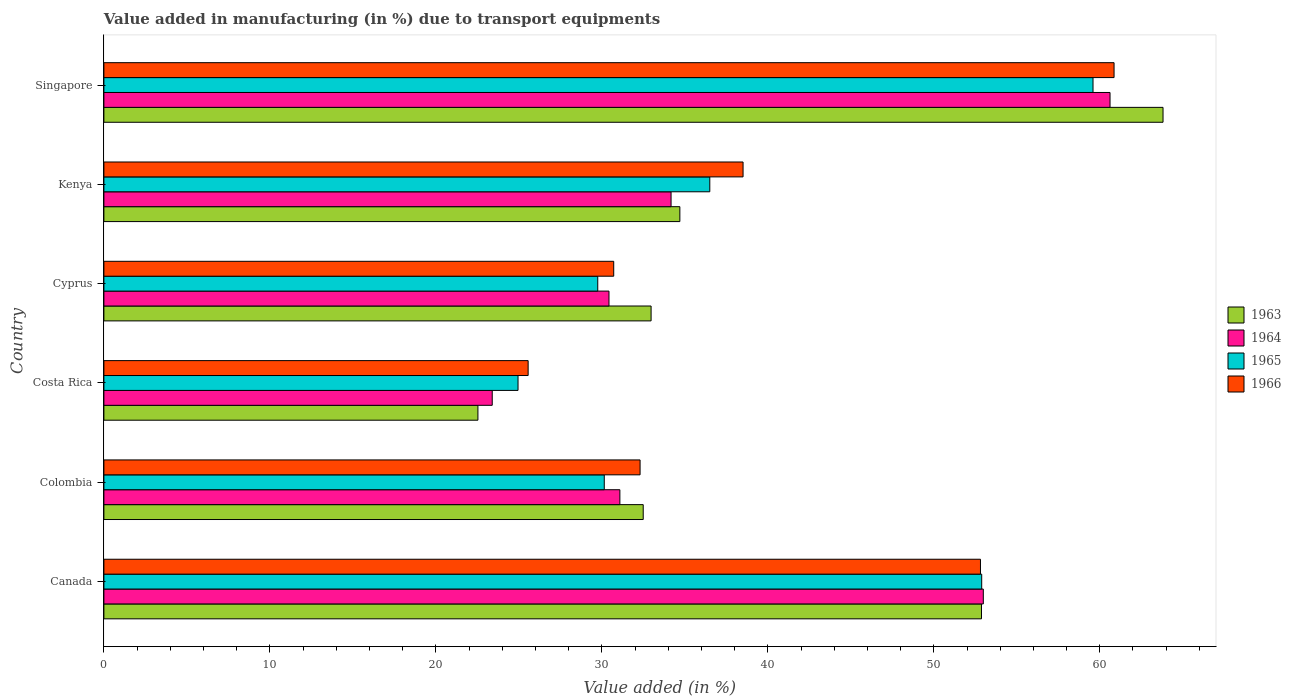How many groups of bars are there?
Offer a terse response. 6. Are the number of bars per tick equal to the number of legend labels?
Keep it short and to the point. Yes. Are the number of bars on each tick of the Y-axis equal?
Make the answer very short. Yes. What is the label of the 6th group of bars from the top?
Provide a short and direct response. Canada. In how many cases, is the number of bars for a given country not equal to the number of legend labels?
Your answer should be very brief. 0. What is the percentage of value added in manufacturing due to transport equipments in 1963 in Cyprus?
Your answer should be compact. 32.97. Across all countries, what is the maximum percentage of value added in manufacturing due to transport equipments in 1965?
Your response must be concise. 59.59. Across all countries, what is the minimum percentage of value added in manufacturing due to transport equipments in 1965?
Your answer should be very brief. 24.95. In which country was the percentage of value added in manufacturing due to transport equipments in 1965 maximum?
Provide a short and direct response. Singapore. What is the total percentage of value added in manufacturing due to transport equipments in 1964 in the graph?
Offer a terse response. 232.68. What is the difference between the percentage of value added in manufacturing due to transport equipments in 1964 in Colombia and that in Costa Rica?
Offer a terse response. 7.69. What is the difference between the percentage of value added in manufacturing due to transport equipments in 1965 in Colombia and the percentage of value added in manufacturing due to transport equipments in 1963 in Kenya?
Your answer should be compact. -4.55. What is the average percentage of value added in manufacturing due to transport equipments in 1963 per country?
Offer a terse response. 39.9. What is the difference between the percentage of value added in manufacturing due to transport equipments in 1963 and percentage of value added in manufacturing due to transport equipments in 1965 in Kenya?
Offer a terse response. -1.8. What is the ratio of the percentage of value added in manufacturing due to transport equipments in 1965 in Costa Rica to that in Cyprus?
Give a very brief answer. 0.84. Is the percentage of value added in manufacturing due to transport equipments in 1966 in Cyprus less than that in Kenya?
Give a very brief answer. Yes. What is the difference between the highest and the second highest percentage of value added in manufacturing due to transport equipments in 1964?
Provide a succinct answer. 7.63. What is the difference between the highest and the lowest percentage of value added in manufacturing due to transport equipments in 1966?
Keep it short and to the point. 35.3. In how many countries, is the percentage of value added in manufacturing due to transport equipments in 1966 greater than the average percentage of value added in manufacturing due to transport equipments in 1966 taken over all countries?
Provide a succinct answer. 2. Is it the case that in every country, the sum of the percentage of value added in manufacturing due to transport equipments in 1966 and percentage of value added in manufacturing due to transport equipments in 1964 is greater than the sum of percentage of value added in manufacturing due to transport equipments in 1965 and percentage of value added in manufacturing due to transport equipments in 1963?
Your response must be concise. No. What does the 2nd bar from the bottom in Costa Rica represents?
Provide a short and direct response. 1964. Is it the case that in every country, the sum of the percentage of value added in manufacturing due to transport equipments in 1966 and percentage of value added in manufacturing due to transport equipments in 1964 is greater than the percentage of value added in manufacturing due to transport equipments in 1965?
Your response must be concise. Yes. How many bars are there?
Keep it short and to the point. 24. How many countries are there in the graph?
Your response must be concise. 6. What is the difference between two consecutive major ticks on the X-axis?
Give a very brief answer. 10. Are the values on the major ticks of X-axis written in scientific E-notation?
Your answer should be compact. No. How many legend labels are there?
Your answer should be compact. 4. What is the title of the graph?
Offer a very short reply. Value added in manufacturing (in %) due to transport equipments. Does "1976" appear as one of the legend labels in the graph?
Give a very brief answer. No. What is the label or title of the X-axis?
Provide a short and direct response. Value added (in %). What is the label or title of the Y-axis?
Keep it short and to the point. Country. What is the Value added (in %) in 1963 in Canada?
Keep it short and to the point. 52.87. What is the Value added (in %) of 1964 in Canada?
Give a very brief answer. 52.98. What is the Value added (in %) of 1965 in Canada?
Ensure brevity in your answer.  52.89. What is the Value added (in %) of 1966 in Canada?
Ensure brevity in your answer.  52.81. What is the Value added (in %) in 1963 in Colombia?
Your answer should be very brief. 32.49. What is the Value added (in %) in 1964 in Colombia?
Your answer should be compact. 31.09. What is the Value added (in %) of 1965 in Colombia?
Make the answer very short. 30.15. What is the Value added (in %) in 1966 in Colombia?
Provide a succinct answer. 32.3. What is the Value added (in %) of 1963 in Costa Rica?
Keep it short and to the point. 22.53. What is the Value added (in %) in 1964 in Costa Rica?
Provide a succinct answer. 23.4. What is the Value added (in %) of 1965 in Costa Rica?
Your response must be concise. 24.95. What is the Value added (in %) of 1966 in Costa Rica?
Ensure brevity in your answer.  25.56. What is the Value added (in %) in 1963 in Cyprus?
Your answer should be very brief. 32.97. What is the Value added (in %) in 1964 in Cyprus?
Keep it short and to the point. 30.43. What is the Value added (in %) of 1965 in Cyprus?
Your response must be concise. 29.75. What is the Value added (in %) in 1966 in Cyprus?
Make the answer very short. 30.72. What is the Value added (in %) of 1963 in Kenya?
Your answer should be very brief. 34.7. What is the Value added (in %) of 1964 in Kenya?
Make the answer very short. 34.17. What is the Value added (in %) of 1965 in Kenya?
Your answer should be very brief. 36.5. What is the Value added (in %) in 1966 in Kenya?
Ensure brevity in your answer.  38.51. What is the Value added (in %) of 1963 in Singapore?
Ensure brevity in your answer.  63.81. What is the Value added (in %) of 1964 in Singapore?
Make the answer very short. 60.62. What is the Value added (in %) of 1965 in Singapore?
Make the answer very short. 59.59. What is the Value added (in %) in 1966 in Singapore?
Your answer should be compact. 60.86. Across all countries, what is the maximum Value added (in %) in 1963?
Offer a terse response. 63.81. Across all countries, what is the maximum Value added (in %) in 1964?
Provide a succinct answer. 60.62. Across all countries, what is the maximum Value added (in %) of 1965?
Give a very brief answer. 59.59. Across all countries, what is the maximum Value added (in %) in 1966?
Your response must be concise. 60.86. Across all countries, what is the minimum Value added (in %) of 1963?
Make the answer very short. 22.53. Across all countries, what is the minimum Value added (in %) in 1964?
Keep it short and to the point. 23.4. Across all countries, what is the minimum Value added (in %) in 1965?
Your answer should be compact. 24.95. Across all countries, what is the minimum Value added (in %) of 1966?
Ensure brevity in your answer.  25.56. What is the total Value added (in %) of 1963 in the graph?
Ensure brevity in your answer.  239.38. What is the total Value added (in %) in 1964 in the graph?
Provide a succinct answer. 232.68. What is the total Value added (in %) in 1965 in the graph?
Provide a short and direct response. 233.83. What is the total Value added (in %) in 1966 in the graph?
Ensure brevity in your answer.  240.76. What is the difference between the Value added (in %) of 1963 in Canada and that in Colombia?
Offer a terse response. 20.38. What is the difference between the Value added (in %) in 1964 in Canada and that in Colombia?
Offer a very short reply. 21.9. What is the difference between the Value added (in %) in 1965 in Canada and that in Colombia?
Your answer should be very brief. 22.74. What is the difference between the Value added (in %) in 1966 in Canada and that in Colombia?
Provide a succinct answer. 20.51. What is the difference between the Value added (in %) in 1963 in Canada and that in Costa Rica?
Make the answer very short. 30.34. What is the difference between the Value added (in %) in 1964 in Canada and that in Costa Rica?
Offer a terse response. 29.59. What is the difference between the Value added (in %) in 1965 in Canada and that in Costa Rica?
Make the answer very short. 27.93. What is the difference between the Value added (in %) of 1966 in Canada and that in Costa Rica?
Keep it short and to the point. 27.25. What is the difference between the Value added (in %) in 1963 in Canada and that in Cyprus?
Provide a short and direct response. 19.91. What is the difference between the Value added (in %) in 1964 in Canada and that in Cyprus?
Keep it short and to the point. 22.55. What is the difference between the Value added (in %) of 1965 in Canada and that in Cyprus?
Your response must be concise. 23.13. What is the difference between the Value added (in %) in 1966 in Canada and that in Cyprus?
Offer a very short reply. 22.1. What is the difference between the Value added (in %) of 1963 in Canada and that in Kenya?
Your response must be concise. 18.17. What is the difference between the Value added (in %) of 1964 in Canada and that in Kenya?
Your response must be concise. 18.81. What is the difference between the Value added (in %) in 1965 in Canada and that in Kenya?
Provide a short and direct response. 16.38. What is the difference between the Value added (in %) in 1966 in Canada and that in Kenya?
Provide a succinct answer. 14.3. What is the difference between the Value added (in %) in 1963 in Canada and that in Singapore?
Make the answer very short. -10.94. What is the difference between the Value added (in %) in 1964 in Canada and that in Singapore?
Provide a short and direct response. -7.63. What is the difference between the Value added (in %) of 1965 in Canada and that in Singapore?
Ensure brevity in your answer.  -6.71. What is the difference between the Value added (in %) in 1966 in Canada and that in Singapore?
Provide a short and direct response. -8.05. What is the difference between the Value added (in %) in 1963 in Colombia and that in Costa Rica?
Give a very brief answer. 9.96. What is the difference between the Value added (in %) of 1964 in Colombia and that in Costa Rica?
Your answer should be very brief. 7.69. What is the difference between the Value added (in %) in 1965 in Colombia and that in Costa Rica?
Make the answer very short. 5.2. What is the difference between the Value added (in %) of 1966 in Colombia and that in Costa Rica?
Your response must be concise. 6.74. What is the difference between the Value added (in %) of 1963 in Colombia and that in Cyprus?
Keep it short and to the point. -0.47. What is the difference between the Value added (in %) in 1964 in Colombia and that in Cyprus?
Give a very brief answer. 0.66. What is the difference between the Value added (in %) of 1965 in Colombia and that in Cyprus?
Your answer should be very brief. 0.39. What is the difference between the Value added (in %) of 1966 in Colombia and that in Cyprus?
Ensure brevity in your answer.  1.59. What is the difference between the Value added (in %) of 1963 in Colombia and that in Kenya?
Make the answer very short. -2.21. What is the difference between the Value added (in %) in 1964 in Colombia and that in Kenya?
Give a very brief answer. -3.08. What is the difference between the Value added (in %) of 1965 in Colombia and that in Kenya?
Provide a succinct answer. -6.36. What is the difference between the Value added (in %) in 1966 in Colombia and that in Kenya?
Your response must be concise. -6.2. What is the difference between the Value added (in %) of 1963 in Colombia and that in Singapore?
Give a very brief answer. -31.32. What is the difference between the Value added (in %) in 1964 in Colombia and that in Singapore?
Make the answer very short. -29.53. What is the difference between the Value added (in %) of 1965 in Colombia and that in Singapore?
Keep it short and to the point. -29.45. What is the difference between the Value added (in %) in 1966 in Colombia and that in Singapore?
Offer a terse response. -28.56. What is the difference between the Value added (in %) in 1963 in Costa Rica and that in Cyprus?
Make the answer very short. -10.43. What is the difference between the Value added (in %) in 1964 in Costa Rica and that in Cyprus?
Provide a succinct answer. -7.03. What is the difference between the Value added (in %) of 1965 in Costa Rica and that in Cyprus?
Keep it short and to the point. -4.8. What is the difference between the Value added (in %) in 1966 in Costa Rica and that in Cyprus?
Offer a terse response. -5.16. What is the difference between the Value added (in %) of 1963 in Costa Rica and that in Kenya?
Provide a short and direct response. -12.17. What is the difference between the Value added (in %) in 1964 in Costa Rica and that in Kenya?
Offer a very short reply. -10.77. What is the difference between the Value added (in %) of 1965 in Costa Rica and that in Kenya?
Keep it short and to the point. -11.55. What is the difference between the Value added (in %) in 1966 in Costa Rica and that in Kenya?
Make the answer very short. -12.95. What is the difference between the Value added (in %) in 1963 in Costa Rica and that in Singapore?
Your answer should be very brief. -41.28. What is the difference between the Value added (in %) in 1964 in Costa Rica and that in Singapore?
Offer a terse response. -37.22. What is the difference between the Value added (in %) of 1965 in Costa Rica and that in Singapore?
Ensure brevity in your answer.  -34.64. What is the difference between the Value added (in %) in 1966 in Costa Rica and that in Singapore?
Your answer should be compact. -35.3. What is the difference between the Value added (in %) in 1963 in Cyprus and that in Kenya?
Your answer should be compact. -1.73. What is the difference between the Value added (in %) in 1964 in Cyprus and that in Kenya?
Your answer should be compact. -3.74. What is the difference between the Value added (in %) of 1965 in Cyprus and that in Kenya?
Your answer should be very brief. -6.75. What is the difference between the Value added (in %) of 1966 in Cyprus and that in Kenya?
Ensure brevity in your answer.  -7.79. What is the difference between the Value added (in %) in 1963 in Cyprus and that in Singapore?
Ensure brevity in your answer.  -30.84. What is the difference between the Value added (in %) of 1964 in Cyprus and that in Singapore?
Provide a short and direct response. -30.19. What is the difference between the Value added (in %) of 1965 in Cyprus and that in Singapore?
Offer a very short reply. -29.84. What is the difference between the Value added (in %) of 1966 in Cyprus and that in Singapore?
Provide a succinct answer. -30.14. What is the difference between the Value added (in %) of 1963 in Kenya and that in Singapore?
Give a very brief answer. -29.11. What is the difference between the Value added (in %) in 1964 in Kenya and that in Singapore?
Your response must be concise. -26.45. What is the difference between the Value added (in %) of 1965 in Kenya and that in Singapore?
Make the answer very short. -23.09. What is the difference between the Value added (in %) of 1966 in Kenya and that in Singapore?
Provide a succinct answer. -22.35. What is the difference between the Value added (in %) in 1963 in Canada and the Value added (in %) in 1964 in Colombia?
Your answer should be very brief. 21.79. What is the difference between the Value added (in %) of 1963 in Canada and the Value added (in %) of 1965 in Colombia?
Your response must be concise. 22.73. What is the difference between the Value added (in %) in 1963 in Canada and the Value added (in %) in 1966 in Colombia?
Make the answer very short. 20.57. What is the difference between the Value added (in %) of 1964 in Canada and the Value added (in %) of 1965 in Colombia?
Offer a very short reply. 22.84. What is the difference between the Value added (in %) in 1964 in Canada and the Value added (in %) in 1966 in Colombia?
Offer a terse response. 20.68. What is the difference between the Value added (in %) of 1965 in Canada and the Value added (in %) of 1966 in Colombia?
Your answer should be compact. 20.58. What is the difference between the Value added (in %) in 1963 in Canada and the Value added (in %) in 1964 in Costa Rica?
Your answer should be compact. 29.48. What is the difference between the Value added (in %) in 1963 in Canada and the Value added (in %) in 1965 in Costa Rica?
Your response must be concise. 27.92. What is the difference between the Value added (in %) of 1963 in Canada and the Value added (in %) of 1966 in Costa Rica?
Ensure brevity in your answer.  27.31. What is the difference between the Value added (in %) in 1964 in Canada and the Value added (in %) in 1965 in Costa Rica?
Your response must be concise. 28.03. What is the difference between the Value added (in %) in 1964 in Canada and the Value added (in %) in 1966 in Costa Rica?
Ensure brevity in your answer.  27.42. What is the difference between the Value added (in %) of 1965 in Canada and the Value added (in %) of 1966 in Costa Rica?
Your answer should be very brief. 27.33. What is the difference between the Value added (in %) in 1963 in Canada and the Value added (in %) in 1964 in Cyprus?
Make the answer very short. 22.44. What is the difference between the Value added (in %) in 1963 in Canada and the Value added (in %) in 1965 in Cyprus?
Offer a terse response. 23.12. What is the difference between the Value added (in %) in 1963 in Canada and the Value added (in %) in 1966 in Cyprus?
Ensure brevity in your answer.  22.16. What is the difference between the Value added (in %) of 1964 in Canada and the Value added (in %) of 1965 in Cyprus?
Offer a terse response. 23.23. What is the difference between the Value added (in %) of 1964 in Canada and the Value added (in %) of 1966 in Cyprus?
Give a very brief answer. 22.27. What is the difference between the Value added (in %) of 1965 in Canada and the Value added (in %) of 1966 in Cyprus?
Ensure brevity in your answer.  22.17. What is the difference between the Value added (in %) of 1963 in Canada and the Value added (in %) of 1964 in Kenya?
Give a very brief answer. 18.7. What is the difference between the Value added (in %) in 1963 in Canada and the Value added (in %) in 1965 in Kenya?
Keep it short and to the point. 16.37. What is the difference between the Value added (in %) in 1963 in Canada and the Value added (in %) in 1966 in Kenya?
Give a very brief answer. 14.37. What is the difference between the Value added (in %) of 1964 in Canada and the Value added (in %) of 1965 in Kenya?
Your answer should be compact. 16.48. What is the difference between the Value added (in %) in 1964 in Canada and the Value added (in %) in 1966 in Kenya?
Provide a short and direct response. 14.47. What is the difference between the Value added (in %) of 1965 in Canada and the Value added (in %) of 1966 in Kenya?
Keep it short and to the point. 14.38. What is the difference between the Value added (in %) in 1963 in Canada and the Value added (in %) in 1964 in Singapore?
Offer a terse response. -7.74. What is the difference between the Value added (in %) in 1963 in Canada and the Value added (in %) in 1965 in Singapore?
Your answer should be very brief. -6.72. What is the difference between the Value added (in %) of 1963 in Canada and the Value added (in %) of 1966 in Singapore?
Your answer should be compact. -7.99. What is the difference between the Value added (in %) in 1964 in Canada and the Value added (in %) in 1965 in Singapore?
Make the answer very short. -6.61. What is the difference between the Value added (in %) of 1964 in Canada and the Value added (in %) of 1966 in Singapore?
Your response must be concise. -7.88. What is the difference between the Value added (in %) of 1965 in Canada and the Value added (in %) of 1966 in Singapore?
Provide a short and direct response. -7.97. What is the difference between the Value added (in %) in 1963 in Colombia and the Value added (in %) in 1964 in Costa Rica?
Your answer should be compact. 9.1. What is the difference between the Value added (in %) of 1963 in Colombia and the Value added (in %) of 1965 in Costa Rica?
Your answer should be compact. 7.54. What is the difference between the Value added (in %) of 1963 in Colombia and the Value added (in %) of 1966 in Costa Rica?
Your answer should be very brief. 6.93. What is the difference between the Value added (in %) in 1964 in Colombia and the Value added (in %) in 1965 in Costa Rica?
Provide a short and direct response. 6.14. What is the difference between the Value added (in %) in 1964 in Colombia and the Value added (in %) in 1966 in Costa Rica?
Keep it short and to the point. 5.53. What is the difference between the Value added (in %) of 1965 in Colombia and the Value added (in %) of 1966 in Costa Rica?
Your response must be concise. 4.59. What is the difference between the Value added (in %) in 1963 in Colombia and the Value added (in %) in 1964 in Cyprus?
Provide a succinct answer. 2.06. What is the difference between the Value added (in %) in 1963 in Colombia and the Value added (in %) in 1965 in Cyprus?
Provide a succinct answer. 2.74. What is the difference between the Value added (in %) of 1963 in Colombia and the Value added (in %) of 1966 in Cyprus?
Give a very brief answer. 1.78. What is the difference between the Value added (in %) of 1964 in Colombia and the Value added (in %) of 1965 in Cyprus?
Your answer should be very brief. 1.33. What is the difference between the Value added (in %) in 1964 in Colombia and the Value added (in %) in 1966 in Cyprus?
Your answer should be compact. 0.37. What is the difference between the Value added (in %) of 1965 in Colombia and the Value added (in %) of 1966 in Cyprus?
Provide a short and direct response. -0.57. What is the difference between the Value added (in %) of 1963 in Colombia and the Value added (in %) of 1964 in Kenya?
Your answer should be very brief. -1.68. What is the difference between the Value added (in %) of 1963 in Colombia and the Value added (in %) of 1965 in Kenya?
Your answer should be very brief. -4.01. What is the difference between the Value added (in %) of 1963 in Colombia and the Value added (in %) of 1966 in Kenya?
Ensure brevity in your answer.  -6.01. What is the difference between the Value added (in %) in 1964 in Colombia and the Value added (in %) in 1965 in Kenya?
Ensure brevity in your answer.  -5.42. What is the difference between the Value added (in %) of 1964 in Colombia and the Value added (in %) of 1966 in Kenya?
Provide a succinct answer. -7.42. What is the difference between the Value added (in %) of 1965 in Colombia and the Value added (in %) of 1966 in Kenya?
Offer a very short reply. -8.36. What is the difference between the Value added (in %) of 1963 in Colombia and the Value added (in %) of 1964 in Singapore?
Keep it short and to the point. -28.12. What is the difference between the Value added (in %) of 1963 in Colombia and the Value added (in %) of 1965 in Singapore?
Provide a short and direct response. -27.1. What is the difference between the Value added (in %) of 1963 in Colombia and the Value added (in %) of 1966 in Singapore?
Your answer should be very brief. -28.37. What is the difference between the Value added (in %) of 1964 in Colombia and the Value added (in %) of 1965 in Singapore?
Give a very brief answer. -28.51. What is the difference between the Value added (in %) in 1964 in Colombia and the Value added (in %) in 1966 in Singapore?
Your answer should be very brief. -29.77. What is the difference between the Value added (in %) of 1965 in Colombia and the Value added (in %) of 1966 in Singapore?
Give a very brief answer. -30.71. What is the difference between the Value added (in %) of 1963 in Costa Rica and the Value added (in %) of 1964 in Cyprus?
Make the answer very short. -7.9. What is the difference between the Value added (in %) in 1963 in Costa Rica and the Value added (in %) in 1965 in Cyprus?
Your answer should be compact. -7.22. What is the difference between the Value added (in %) of 1963 in Costa Rica and the Value added (in %) of 1966 in Cyprus?
Provide a short and direct response. -8.18. What is the difference between the Value added (in %) in 1964 in Costa Rica and the Value added (in %) in 1965 in Cyprus?
Ensure brevity in your answer.  -6.36. What is the difference between the Value added (in %) in 1964 in Costa Rica and the Value added (in %) in 1966 in Cyprus?
Offer a very short reply. -7.32. What is the difference between the Value added (in %) in 1965 in Costa Rica and the Value added (in %) in 1966 in Cyprus?
Provide a succinct answer. -5.77. What is the difference between the Value added (in %) in 1963 in Costa Rica and the Value added (in %) in 1964 in Kenya?
Keep it short and to the point. -11.64. What is the difference between the Value added (in %) of 1963 in Costa Rica and the Value added (in %) of 1965 in Kenya?
Ensure brevity in your answer.  -13.97. What is the difference between the Value added (in %) in 1963 in Costa Rica and the Value added (in %) in 1966 in Kenya?
Your response must be concise. -15.97. What is the difference between the Value added (in %) in 1964 in Costa Rica and the Value added (in %) in 1965 in Kenya?
Your answer should be compact. -13.11. What is the difference between the Value added (in %) in 1964 in Costa Rica and the Value added (in %) in 1966 in Kenya?
Give a very brief answer. -15.11. What is the difference between the Value added (in %) of 1965 in Costa Rica and the Value added (in %) of 1966 in Kenya?
Offer a terse response. -13.56. What is the difference between the Value added (in %) of 1963 in Costa Rica and the Value added (in %) of 1964 in Singapore?
Your response must be concise. -38.08. What is the difference between the Value added (in %) in 1963 in Costa Rica and the Value added (in %) in 1965 in Singapore?
Offer a terse response. -37.06. What is the difference between the Value added (in %) of 1963 in Costa Rica and the Value added (in %) of 1966 in Singapore?
Provide a short and direct response. -38.33. What is the difference between the Value added (in %) in 1964 in Costa Rica and the Value added (in %) in 1965 in Singapore?
Offer a terse response. -36.19. What is the difference between the Value added (in %) of 1964 in Costa Rica and the Value added (in %) of 1966 in Singapore?
Ensure brevity in your answer.  -37.46. What is the difference between the Value added (in %) in 1965 in Costa Rica and the Value added (in %) in 1966 in Singapore?
Offer a terse response. -35.91. What is the difference between the Value added (in %) in 1963 in Cyprus and the Value added (in %) in 1964 in Kenya?
Keep it short and to the point. -1.2. What is the difference between the Value added (in %) in 1963 in Cyprus and the Value added (in %) in 1965 in Kenya?
Give a very brief answer. -3.54. What is the difference between the Value added (in %) of 1963 in Cyprus and the Value added (in %) of 1966 in Kenya?
Offer a very short reply. -5.54. What is the difference between the Value added (in %) in 1964 in Cyprus and the Value added (in %) in 1965 in Kenya?
Offer a terse response. -6.07. What is the difference between the Value added (in %) of 1964 in Cyprus and the Value added (in %) of 1966 in Kenya?
Provide a short and direct response. -8.08. What is the difference between the Value added (in %) of 1965 in Cyprus and the Value added (in %) of 1966 in Kenya?
Make the answer very short. -8.75. What is the difference between the Value added (in %) of 1963 in Cyprus and the Value added (in %) of 1964 in Singapore?
Your response must be concise. -27.65. What is the difference between the Value added (in %) in 1963 in Cyprus and the Value added (in %) in 1965 in Singapore?
Offer a very short reply. -26.62. What is the difference between the Value added (in %) of 1963 in Cyprus and the Value added (in %) of 1966 in Singapore?
Provide a short and direct response. -27.89. What is the difference between the Value added (in %) in 1964 in Cyprus and the Value added (in %) in 1965 in Singapore?
Offer a terse response. -29.16. What is the difference between the Value added (in %) of 1964 in Cyprus and the Value added (in %) of 1966 in Singapore?
Your response must be concise. -30.43. What is the difference between the Value added (in %) in 1965 in Cyprus and the Value added (in %) in 1966 in Singapore?
Give a very brief answer. -31.11. What is the difference between the Value added (in %) of 1963 in Kenya and the Value added (in %) of 1964 in Singapore?
Provide a succinct answer. -25.92. What is the difference between the Value added (in %) in 1963 in Kenya and the Value added (in %) in 1965 in Singapore?
Give a very brief answer. -24.89. What is the difference between the Value added (in %) in 1963 in Kenya and the Value added (in %) in 1966 in Singapore?
Provide a succinct answer. -26.16. What is the difference between the Value added (in %) of 1964 in Kenya and the Value added (in %) of 1965 in Singapore?
Your answer should be very brief. -25.42. What is the difference between the Value added (in %) in 1964 in Kenya and the Value added (in %) in 1966 in Singapore?
Offer a very short reply. -26.69. What is the difference between the Value added (in %) of 1965 in Kenya and the Value added (in %) of 1966 in Singapore?
Offer a terse response. -24.36. What is the average Value added (in %) in 1963 per country?
Offer a terse response. 39.9. What is the average Value added (in %) of 1964 per country?
Provide a short and direct response. 38.78. What is the average Value added (in %) in 1965 per country?
Your answer should be very brief. 38.97. What is the average Value added (in %) in 1966 per country?
Your answer should be very brief. 40.13. What is the difference between the Value added (in %) in 1963 and Value added (in %) in 1964 in Canada?
Your answer should be compact. -0.11. What is the difference between the Value added (in %) of 1963 and Value added (in %) of 1965 in Canada?
Offer a terse response. -0.01. What is the difference between the Value added (in %) of 1963 and Value added (in %) of 1966 in Canada?
Keep it short and to the point. 0.06. What is the difference between the Value added (in %) of 1964 and Value added (in %) of 1965 in Canada?
Keep it short and to the point. 0.1. What is the difference between the Value added (in %) in 1964 and Value added (in %) in 1966 in Canada?
Keep it short and to the point. 0.17. What is the difference between the Value added (in %) in 1965 and Value added (in %) in 1966 in Canada?
Keep it short and to the point. 0.07. What is the difference between the Value added (in %) of 1963 and Value added (in %) of 1964 in Colombia?
Your response must be concise. 1.41. What is the difference between the Value added (in %) of 1963 and Value added (in %) of 1965 in Colombia?
Keep it short and to the point. 2.35. What is the difference between the Value added (in %) in 1963 and Value added (in %) in 1966 in Colombia?
Offer a terse response. 0.19. What is the difference between the Value added (in %) in 1964 and Value added (in %) in 1965 in Colombia?
Your response must be concise. 0.94. What is the difference between the Value added (in %) of 1964 and Value added (in %) of 1966 in Colombia?
Give a very brief answer. -1.22. What is the difference between the Value added (in %) in 1965 and Value added (in %) in 1966 in Colombia?
Give a very brief answer. -2.16. What is the difference between the Value added (in %) in 1963 and Value added (in %) in 1964 in Costa Rica?
Make the answer very short. -0.86. What is the difference between the Value added (in %) in 1963 and Value added (in %) in 1965 in Costa Rica?
Offer a terse response. -2.42. What is the difference between the Value added (in %) in 1963 and Value added (in %) in 1966 in Costa Rica?
Your response must be concise. -3.03. What is the difference between the Value added (in %) of 1964 and Value added (in %) of 1965 in Costa Rica?
Your response must be concise. -1.55. What is the difference between the Value added (in %) in 1964 and Value added (in %) in 1966 in Costa Rica?
Offer a very short reply. -2.16. What is the difference between the Value added (in %) of 1965 and Value added (in %) of 1966 in Costa Rica?
Your answer should be very brief. -0.61. What is the difference between the Value added (in %) in 1963 and Value added (in %) in 1964 in Cyprus?
Your answer should be very brief. 2.54. What is the difference between the Value added (in %) in 1963 and Value added (in %) in 1965 in Cyprus?
Your answer should be compact. 3.21. What is the difference between the Value added (in %) of 1963 and Value added (in %) of 1966 in Cyprus?
Offer a very short reply. 2.25. What is the difference between the Value added (in %) of 1964 and Value added (in %) of 1965 in Cyprus?
Make the answer very short. 0.68. What is the difference between the Value added (in %) of 1964 and Value added (in %) of 1966 in Cyprus?
Your response must be concise. -0.29. What is the difference between the Value added (in %) of 1965 and Value added (in %) of 1966 in Cyprus?
Your answer should be compact. -0.96. What is the difference between the Value added (in %) of 1963 and Value added (in %) of 1964 in Kenya?
Your answer should be very brief. 0.53. What is the difference between the Value added (in %) of 1963 and Value added (in %) of 1965 in Kenya?
Provide a succinct answer. -1.8. What is the difference between the Value added (in %) in 1963 and Value added (in %) in 1966 in Kenya?
Give a very brief answer. -3.81. What is the difference between the Value added (in %) in 1964 and Value added (in %) in 1965 in Kenya?
Provide a succinct answer. -2.33. What is the difference between the Value added (in %) of 1964 and Value added (in %) of 1966 in Kenya?
Offer a terse response. -4.34. What is the difference between the Value added (in %) in 1965 and Value added (in %) in 1966 in Kenya?
Offer a very short reply. -2. What is the difference between the Value added (in %) of 1963 and Value added (in %) of 1964 in Singapore?
Keep it short and to the point. 3.19. What is the difference between the Value added (in %) in 1963 and Value added (in %) in 1965 in Singapore?
Provide a succinct answer. 4.22. What is the difference between the Value added (in %) of 1963 and Value added (in %) of 1966 in Singapore?
Your answer should be very brief. 2.95. What is the difference between the Value added (in %) in 1964 and Value added (in %) in 1965 in Singapore?
Provide a short and direct response. 1.03. What is the difference between the Value added (in %) of 1964 and Value added (in %) of 1966 in Singapore?
Provide a succinct answer. -0.24. What is the difference between the Value added (in %) in 1965 and Value added (in %) in 1966 in Singapore?
Give a very brief answer. -1.27. What is the ratio of the Value added (in %) of 1963 in Canada to that in Colombia?
Make the answer very short. 1.63. What is the ratio of the Value added (in %) in 1964 in Canada to that in Colombia?
Your answer should be very brief. 1.7. What is the ratio of the Value added (in %) of 1965 in Canada to that in Colombia?
Give a very brief answer. 1.75. What is the ratio of the Value added (in %) in 1966 in Canada to that in Colombia?
Offer a terse response. 1.63. What is the ratio of the Value added (in %) in 1963 in Canada to that in Costa Rica?
Ensure brevity in your answer.  2.35. What is the ratio of the Value added (in %) of 1964 in Canada to that in Costa Rica?
Give a very brief answer. 2.26. What is the ratio of the Value added (in %) of 1965 in Canada to that in Costa Rica?
Make the answer very short. 2.12. What is the ratio of the Value added (in %) of 1966 in Canada to that in Costa Rica?
Keep it short and to the point. 2.07. What is the ratio of the Value added (in %) of 1963 in Canada to that in Cyprus?
Offer a very short reply. 1.6. What is the ratio of the Value added (in %) in 1964 in Canada to that in Cyprus?
Make the answer very short. 1.74. What is the ratio of the Value added (in %) of 1965 in Canada to that in Cyprus?
Keep it short and to the point. 1.78. What is the ratio of the Value added (in %) in 1966 in Canada to that in Cyprus?
Make the answer very short. 1.72. What is the ratio of the Value added (in %) of 1963 in Canada to that in Kenya?
Your response must be concise. 1.52. What is the ratio of the Value added (in %) of 1964 in Canada to that in Kenya?
Your answer should be very brief. 1.55. What is the ratio of the Value added (in %) of 1965 in Canada to that in Kenya?
Your answer should be very brief. 1.45. What is the ratio of the Value added (in %) in 1966 in Canada to that in Kenya?
Give a very brief answer. 1.37. What is the ratio of the Value added (in %) in 1963 in Canada to that in Singapore?
Keep it short and to the point. 0.83. What is the ratio of the Value added (in %) in 1964 in Canada to that in Singapore?
Offer a very short reply. 0.87. What is the ratio of the Value added (in %) in 1965 in Canada to that in Singapore?
Provide a short and direct response. 0.89. What is the ratio of the Value added (in %) of 1966 in Canada to that in Singapore?
Provide a succinct answer. 0.87. What is the ratio of the Value added (in %) in 1963 in Colombia to that in Costa Rica?
Offer a very short reply. 1.44. What is the ratio of the Value added (in %) in 1964 in Colombia to that in Costa Rica?
Ensure brevity in your answer.  1.33. What is the ratio of the Value added (in %) of 1965 in Colombia to that in Costa Rica?
Offer a terse response. 1.21. What is the ratio of the Value added (in %) of 1966 in Colombia to that in Costa Rica?
Your answer should be very brief. 1.26. What is the ratio of the Value added (in %) in 1963 in Colombia to that in Cyprus?
Make the answer very short. 0.99. What is the ratio of the Value added (in %) in 1964 in Colombia to that in Cyprus?
Keep it short and to the point. 1.02. What is the ratio of the Value added (in %) in 1965 in Colombia to that in Cyprus?
Ensure brevity in your answer.  1.01. What is the ratio of the Value added (in %) of 1966 in Colombia to that in Cyprus?
Give a very brief answer. 1.05. What is the ratio of the Value added (in %) of 1963 in Colombia to that in Kenya?
Your answer should be compact. 0.94. What is the ratio of the Value added (in %) in 1964 in Colombia to that in Kenya?
Give a very brief answer. 0.91. What is the ratio of the Value added (in %) in 1965 in Colombia to that in Kenya?
Ensure brevity in your answer.  0.83. What is the ratio of the Value added (in %) in 1966 in Colombia to that in Kenya?
Give a very brief answer. 0.84. What is the ratio of the Value added (in %) in 1963 in Colombia to that in Singapore?
Offer a terse response. 0.51. What is the ratio of the Value added (in %) in 1964 in Colombia to that in Singapore?
Your answer should be compact. 0.51. What is the ratio of the Value added (in %) of 1965 in Colombia to that in Singapore?
Provide a short and direct response. 0.51. What is the ratio of the Value added (in %) of 1966 in Colombia to that in Singapore?
Offer a very short reply. 0.53. What is the ratio of the Value added (in %) in 1963 in Costa Rica to that in Cyprus?
Offer a terse response. 0.68. What is the ratio of the Value added (in %) of 1964 in Costa Rica to that in Cyprus?
Provide a succinct answer. 0.77. What is the ratio of the Value added (in %) in 1965 in Costa Rica to that in Cyprus?
Your response must be concise. 0.84. What is the ratio of the Value added (in %) of 1966 in Costa Rica to that in Cyprus?
Keep it short and to the point. 0.83. What is the ratio of the Value added (in %) in 1963 in Costa Rica to that in Kenya?
Your answer should be very brief. 0.65. What is the ratio of the Value added (in %) in 1964 in Costa Rica to that in Kenya?
Make the answer very short. 0.68. What is the ratio of the Value added (in %) in 1965 in Costa Rica to that in Kenya?
Offer a terse response. 0.68. What is the ratio of the Value added (in %) of 1966 in Costa Rica to that in Kenya?
Offer a terse response. 0.66. What is the ratio of the Value added (in %) of 1963 in Costa Rica to that in Singapore?
Make the answer very short. 0.35. What is the ratio of the Value added (in %) of 1964 in Costa Rica to that in Singapore?
Provide a short and direct response. 0.39. What is the ratio of the Value added (in %) of 1965 in Costa Rica to that in Singapore?
Your answer should be compact. 0.42. What is the ratio of the Value added (in %) of 1966 in Costa Rica to that in Singapore?
Your answer should be compact. 0.42. What is the ratio of the Value added (in %) of 1963 in Cyprus to that in Kenya?
Ensure brevity in your answer.  0.95. What is the ratio of the Value added (in %) in 1964 in Cyprus to that in Kenya?
Ensure brevity in your answer.  0.89. What is the ratio of the Value added (in %) in 1965 in Cyprus to that in Kenya?
Your response must be concise. 0.82. What is the ratio of the Value added (in %) in 1966 in Cyprus to that in Kenya?
Provide a succinct answer. 0.8. What is the ratio of the Value added (in %) in 1963 in Cyprus to that in Singapore?
Offer a terse response. 0.52. What is the ratio of the Value added (in %) of 1964 in Cyprus to that in Singapore?
Provide a short and direct response. 0.5. What is the ratio of the Value added (in %) of 1965 in Cyprus to that in Singapore?
Keep it short and to the point. 0.5. What is the ratio of the Value added (in %) in 1966 in Cyprus to that in Singapore?
Provide a short and direct response. 0.5. What is the ratio of the Value added (in %) of 1963 in Kenya to that in Singapore?
Ensure brevity in your answer.  0.54. What is the ratio of the Value added (in %) in 1964 in Kenya to that in Singapore?
Provide a short and direct response. 0.56. What is the ratio of the Value added (in %) in 1965 in Kenya to that in Singapore?
Provide a succinct answer. 0.61. What is the ratio of the Value added (in %) in 1966 in Kenya to that in Singapore?
Ensure brevity in your answer.  0.63. What is the difference between the highest and the second highest Value added (in %) in 1963?
Ensure brevity in your answer.  10.94. What is the difference between the highest and the second highest Value added (in %) of 1964?
Your answer should be very brief. 7.63. What is the difference between the highest and the second highest Value added (in %) in 1965?
Offer a very short reply. 6.71. What is the difference between the highest and the second highest Value added (in %) of 1966?
Offer a very short reply. 8.05. What is the difference between the highest and the lowest Value added (in %) in 1963?
Offer a very short reply. 41.28. What is the difference between the highest and the lowest Value added (in %) of 1964?
Make the answer very short. 37.22. What is the difference between the highest and the lowest Value added (in %) of 1965?
Offer a very short reply. 34.64. What is the difference between the highest and the lowest Value added (in %) in 1966?
Provide a short and direct response. 35.3. 